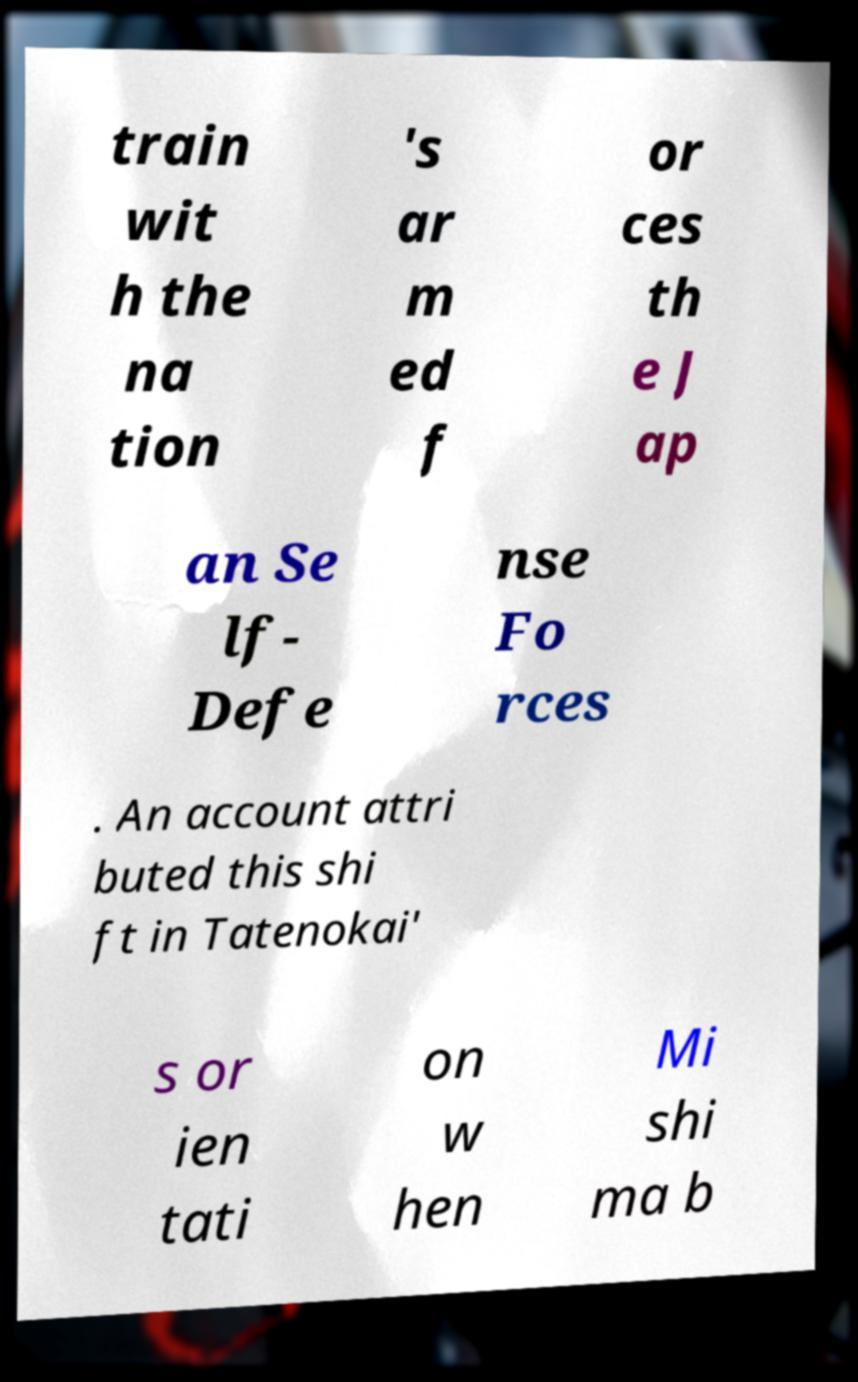I need the written content from this picture converted into text. Can you do that? train wit h the na tion 's ar m ed f or ces th e J ap an Se lf- Defe nse Fo rces . An account attri buted this shi ft in Tatenokai' s or ien tati on w hen Mi shi ma b 